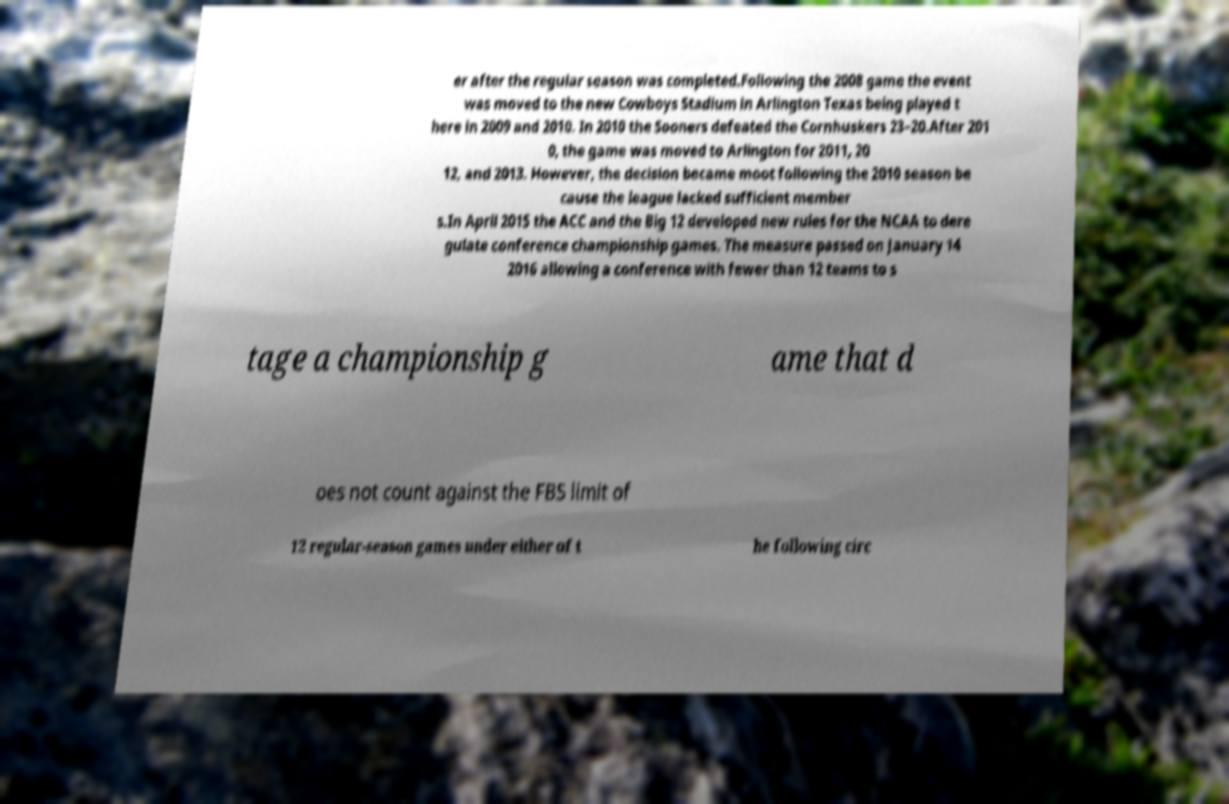Could you extract and type out the text from this image? er after the regular season was completed.Following the 2008 game the event was moved to the new Cowboys Stadium in Arlington Texas being played t here in 2009 and 2010. In 2010 the Sooners defeated the Cornhuskers 23–20.After 201 0, the game was moved to Arlington for 2011, 20 12, and 2013. However, the decision became moot following the 2010 season be cause the league lacked sufficient member s.In April 2015 the ACC and the Big 12 developed new rules for the NCAA to dere gulate conference championship games. The measure passed on January 14 2016 allowing a conference with fewer than 12 teams to s tage a championship g ame that d oes not count against the FBS limit of 12 regular-season games under either of t he following circ 